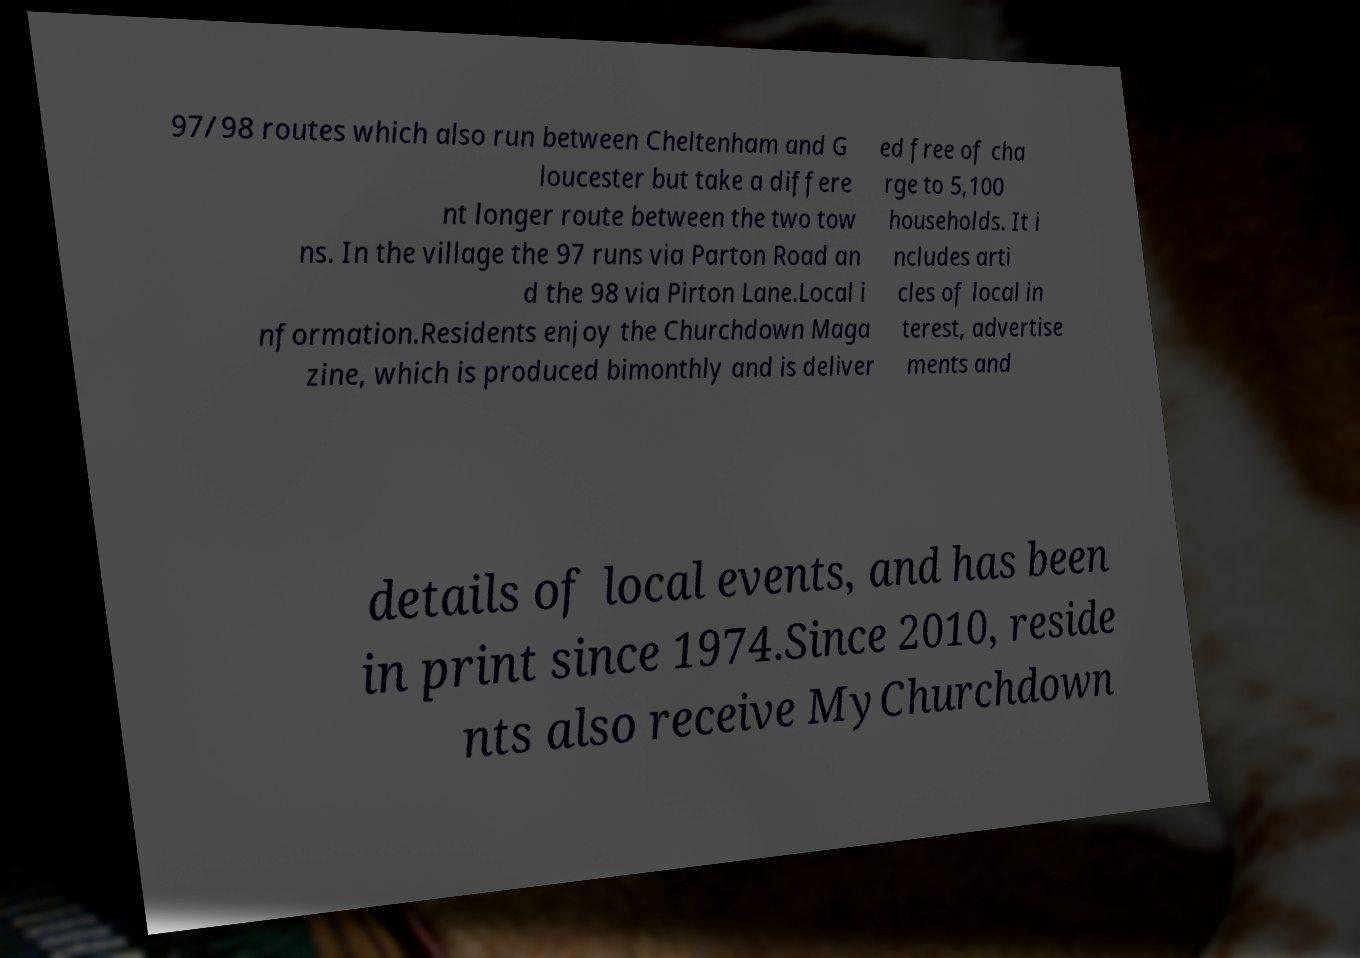Could you assist in decoding the text presented in this image and type it out clearly? 97/98 routes which also run between Cheltenham and G loucester but take a differe nt longer route between the two tow ns. In the village the 97 runs via Parton Road an d the 98 via Pirton Lane.Local i nformation.Residents enjoy the Churchdown Maga zine, which is produced bimonthly and is deliver ed free of cha rge to 5,100 households. It i ncludes arti cles of local in terest, advertise ments and details of local events, and has been in print since 1974.Since 2010, reside nts also receive MyChurchdown 